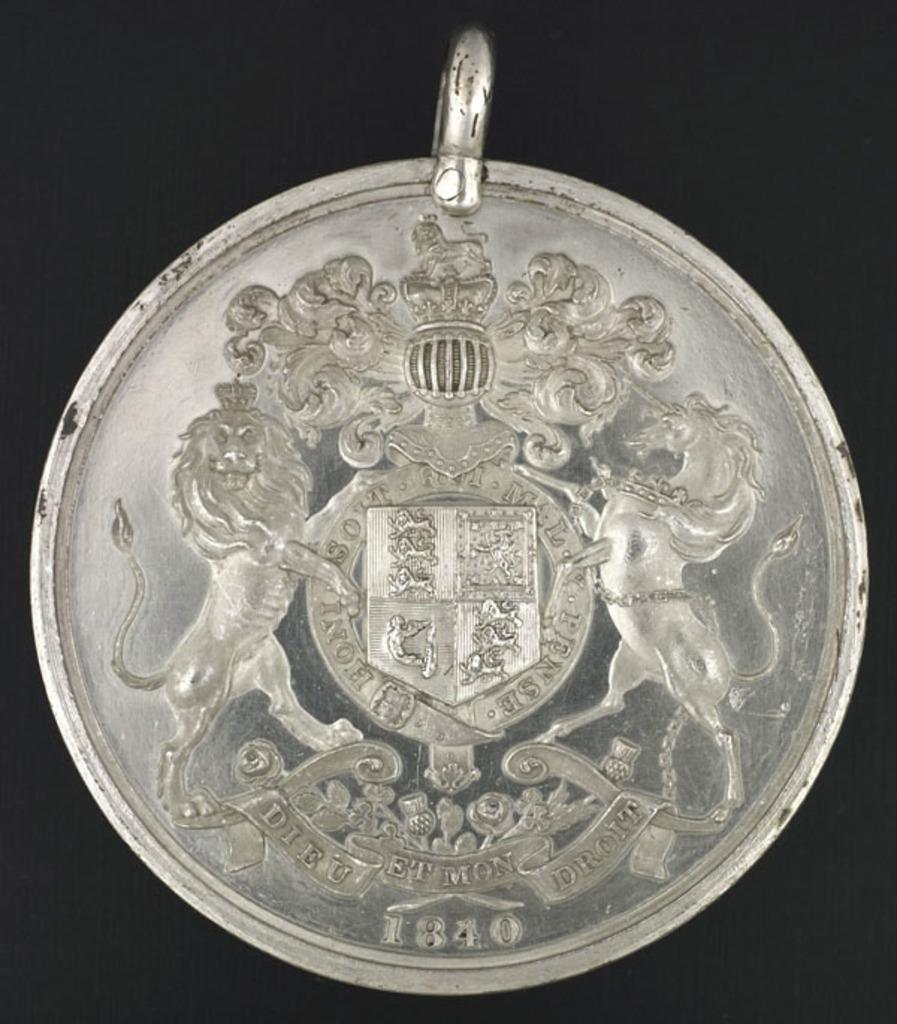What object is the main subject of the picture? The main subject of the picture is a coin. What symbols or images are present on the coin? The coin has lions and a crone on it. What is the color of the background in the image? The background of the image is black. What type of shoes can be seen on the knee in the image? There is no knee or shoes present in the image; it features a coin with lions and a crone on it against a black background. 